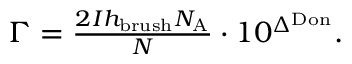<formula> <loc_0><loc_0><loc_500><loc_500>\begin{array} { r } { \Gamma = \frac { 2 I h _ { b r u s h } N _ { A } } { N } \cdot 1 0 ^ { \Delta ^ { D o n } } . } \end{array}</formula> 